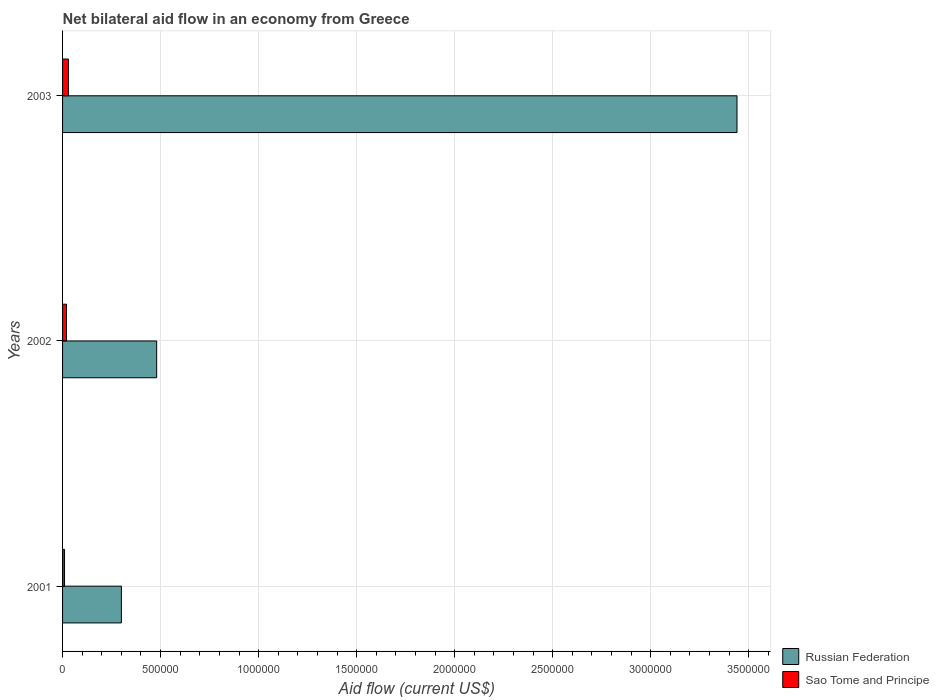How many groups of bars are there?
Provide a succinct answer. 3. Are the number of bars on each tick of the Y-axis equal?
Your answer should be compact. Yes. How many bars are there on the 2nd tick from the bottom?
Your answer should be compact. 2. What is the label of the 1st group of bars from the top?
Offer a terse response. 2003. What is the net bilateral aid flow in Russian Federation in 2003?
Your response must be concise. 3.44e+06. Across all years, what is the minimum net bilateral aid flow in Russian Federation?
Your answer should be very brief. 3.00e+05. In which year was the net bilateral aid flow in Sao Tome and Principe maximum?
Ensure brevity in your answer.  2003. In which year was the net bilateral aid flow in Russian Federation minimum?
Make the answer very short. 2001. What is the total net bilateral aid flow in Russian Federation in the graph?
Keep it short and to the point. 4.22e+06. What is the difference between the net bilateral aid flow in Russian Federation in 2001 and the net bilateral aid flow in Sao Tome and Principe in 2003?
Provide a succinct answer. 2.70e+05. In how many years, is the net bilateral aid flow in Russian Federation greater than 200000 US$?
Keep it short and to the point. 3. What is the ratio of the net bilateral aid flow in Russian Federation in 2001 to that in 2002?
Offer a terse response. 0.62. Is the net bilateral aid flow in Russian Federation in 2001 less than that in 2003?
Offer a terse response. Yes. What is the difference between the highest and the second highest net bilateral aid flow in Sao Tome and Principe?
Your answer should be compact. 10000. What is the difference between the highest and the lowest net bilateral aid flow in Russian Federation?
Ensure brevity in your answer.  3.14e+06. What does the 2nd bar from the top in 2001 represents?
Make the answer very short. Russian Federation. What does the 2nd bar from the bottom in 2002 represents?
Offer a terse response. Sao Tome and Principe. How many bars are there?
Keep it short and to the point. 6. Are all the bars in the graph horizontal?
Your response must be concise. Yes. How many years are there in the graph?
Your answer should be very brief. 3. What is the difference between two consecutive major ticks on the X-axis?
Offer a very short reply. 5.00e+05. Are the values on the major ticks of X-axis written in scientific E-notation?
Offer a very short reply. No. Where does the legend appear in the graph?
Give a very brief answer. Bottom right. How are the legend labels stacked?
Your response must be concise. Vertical. What is the title of the graph?
Offer a very short reply. Net bilateral aid flow in an economy from Greece. Does "Micronesia" appear as one of the legend labels in the graph?
Provide a succinct answer. No. What is the label or title of the Y-axis?
Make the answer very short. Years. What is the Aid flow (current US$) in Russian Federation in 2003?
Make the answer very short. 3.44e+06. What is the Aid flow (current US$) in Sao Tome and Principe in 2003?
Offer a very short reply. 3.00e+04. Across all years, what is the maximum Aid flow (current US$) in Russian Federation?
Offer a terse response. 3.44e+06. Across all years, what is the maximum Aid flow (current US$) in Sao Tome and Principe?
Offer a terse response. 3.00e+04. Across all years, what is the minimum Aid flow (current US$) in Russian Federation?
Give a very brief answer. 3.00e+05. Across all years, what is the minimum Aid flow (current US$) in Sao Tome and Principe?
Offer a terse response. 10000. What is the total Aid flow (current US$) in Russian Federation in the graph?
Your answer should be very brief. 4.22e+06. What is the total Aid flow (current US$) in Sao Tome and Principe in the graph?
Offer a terse response. 6.00e+04. What is the difference between the Aid flow (current US$) in Sao Tome and Principe in 2001 and that in 2002?
Keep it short and to the point. -10000. What is the difference between the Aid flow (current US$) in Russian Federation in 2001 and that in 2003?
Your response must be concise. -3.14e+06. What is the difference between the Aid flow (current US$) of Sao Tome and Principe in 2001 and that in 2003?
Your answer should be very brief. -2.00e+04. What is the difference between the Aid flow (current US$) in Russian Federation in 2002 and that in 2003?
Offer a very short reply. -2.96e+06. What is the difference between the Aid flow (current US$) in Sao Tome and Principe in 2002 and that in 2003?
Keep it short and to the point. -10000. What is the difference between the Aid flow (current US$) of Russian Federation in 2001 and the Aid flow (current US$) of Sao Tome and Principe in 2002?
Provide a succinct answer. 2.80e+05. What is the difference between the Aid flow (current US$) in Russian Federation in 2002 and the Aid flow (current US$) in Sao Tome and Principe in 2003?
Offer a very short reply. 4.50e+05. What is the average Aid flow (current US$) in Russian Federation per year?
Your response must be concise. 1.41e+06. What is the average Aid flow (current US$) of Sao Tome and Principe per year?
Keep it short and to the point. 2.00e+04. In the year 2001, what is the difference between the Aid flow (current US$) in Russian Federation and Aid flow (current US$) in Sao Tome and Principe?
Ensure brevity in your answer.  2.90e+05. In the year 2002, what is the difference between the Aid flow (current US$) in Russian Federation and Aid flow (current US$) in Sao Tome and Principe?
Provide a succinct answer. 4.60e+05. In the year 2003, what is the difference between the Aid flow (current US$) of Russian Federation and Aid flow (current US$) of Sao Tome and Principe?
Give a very brief answer. 3.41e+06. What is the ratio of the Aid flow (current US$) in Russian Federation in 2001 to that in 2002?
Make the answer very short. 0.62. What is the ratio of the Aid flow (current US$) in Sao Tome and Principe in 2001 to that in 2002?
Your answer should be very brief. 0.5. What is the ratio of the Aid flow (current US$) of Russian Federation in 2001 to that in 2003?
Your answer should be compact. 0.09. What is the ratio of the Aid flow (current US$) in Sao Tome and Principe in 2001 to that in 2003?
Ensure brevity in your answer.  0.33. What is the ratio of the Aid flow (current US$) in Russian Federation in 2002 to that in 2003?
Offer a very short reply. 0.14. What is the ratio of the Aid flow (current US$) in Sao Tome and Principe in 2002 to that in 2003?
Offer a very short reply. 0.67. What is the difference between the highest and the second highest Aid flow (current US$) in Russian Federation?
Your answer should be compact. 2.96e+06. What is the difference between the highest and the lowest Aid flow (current US$) of Russian Federation?
Give a very brief answer. 3.14e+06. What is the difference between the highest and the lowest Aid flow (current US$) of Sao Tome and Principe?
Give a very brief answer. 2.00e+04. 